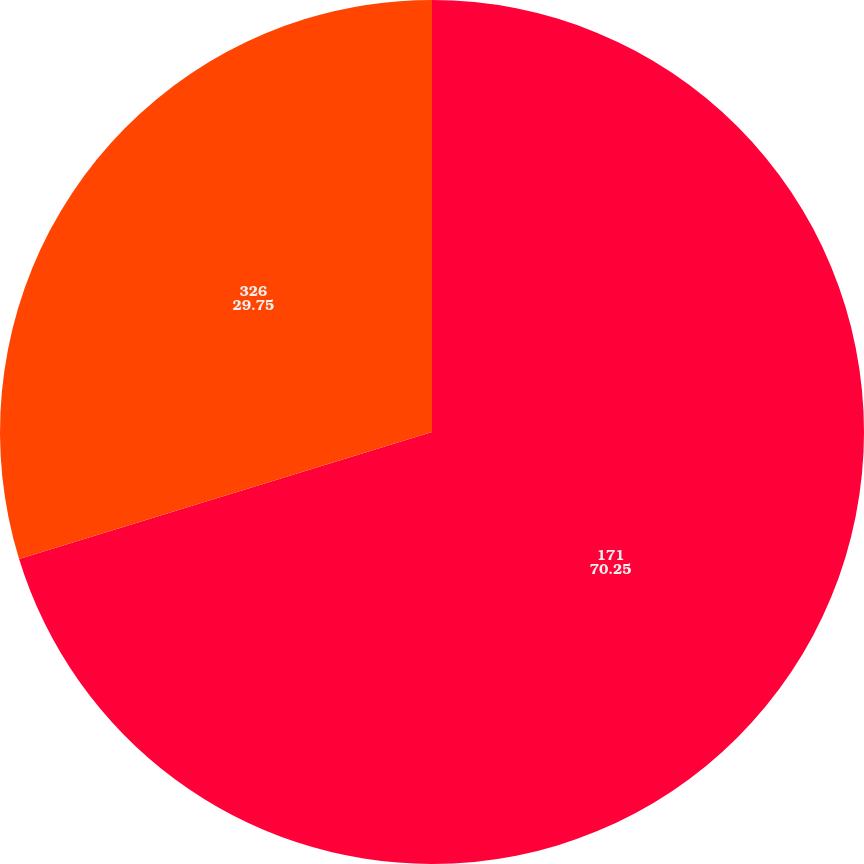<chart> <loc_0><loc_0><loc_500><loc_500><pie_chart><fcel>171<fcel>326<nl><fcel>70.25%<fcel>29.75%<nl></chart> 